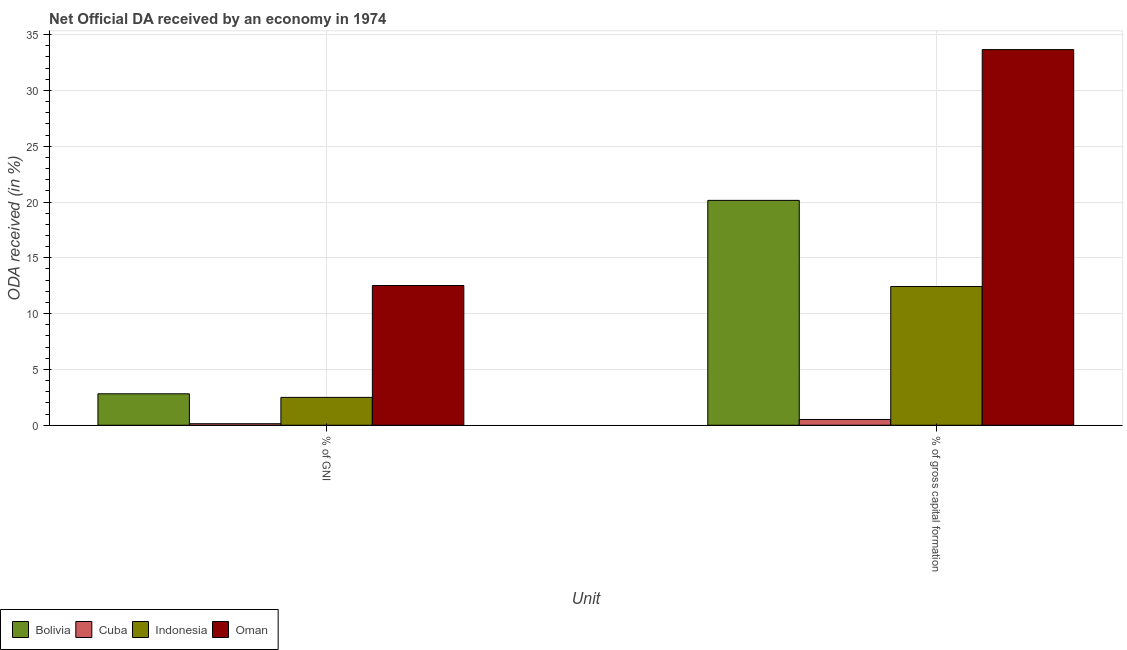How many different coloured bars are there?
Your answer should be compact. 4. Are the number of bars on each tick of the X-axis equal?
Your answer should be compact. Yes. How many bars are there on the 1st tick from the left?
Your answer should be compact. 4. How many bars are there on the 2nd tick from the right?
Offer a very short reply. 4. What is the label of the 2nd group of bars from the left?
Provide a succinct answer. % of gross capital formation. What is the oda received as percentage of gni in Indonesia?
Provide a succinct answer. 2.5. Across all countries, what is the maximum oda received as percentage of gross capital formation?
Keep it short and to the point. 33.65. Across all countries, what is the minimum oda received as percentage of gross capital formation?
Ensure brevity in your answer.  0.52. In which country was the oda received as percentage of gross capital formation maximum?
Offer a very short reply. Oman. In which country was the oda received as percentage of gross capital formation minimum?
Ensure brevity in your answer.  Cuba. What is the total oda received as percentage of gross capital formation in the graph?
Ensure brevity in your answer.  66.74. What is the difference between the oda received as percentage of gni in Indonesia and that in Bolivia?
Ensure brevity in your answer.  -0.32. What is the difference between the oda received as percentage of gni in Oman and the oda received as percentage of gross capital formation in Cuba?
Give a very brief answer. 12. What is the average oda received as percentage of gni per country?
Offer a terse response. 4.49. What is the difference between the oda received as percentage of gni and oda received as percentage of gross capital formation in Cuba?
Provide a succinct answer. -0.38. What is the ratio of the oda received as percentage of gni in Cuba to that in Bolivia?
Provide a short and direct response. 0.05. What does the 3rd bar from the right in % of GNI represents?
Your response must be concise. Cuba. Are all the bars in the graph horizontal?
Keep it short and to the point. No. How many countries are there in the graph?
Your answer should be compact. 4. What is the difference between two consecutive major ticks on the Y-axis?
Keep it short and to the point. 5. Where does the legend appear in the graph?
Keep it short and to the point. Bottom left. How many legend labels are there?
Your answer should be very brief. 4. What is the title of the graph?
Your response must be concise. Net Official DA received by an economy in 1974. What is the label or title of the X-axis?
Make the answer very short. Unit. What is the label or title of the Y-axis?
Your response must be concise. ODA received (in %). What is the ODA received (in %) in Bolivia in % of GNI?
Ensure brevity in your answer.  2.82. What is the ODA received (in %) of Cuba in % of GNI?
Offer a very short reply. 0.14. What is the ODA received (in %) in Indonesia in % of GNI?
Your answer should be compact. 2.5. What is the ODA received (in %) in Oman in % of GNI?
Ensure brevity in your answer.  12.52. What is the ODA received (in %) in Bolivia in % of gross capital formation?
Your answer should be compact. 20.15. What is the ODA received (in %) in Cuba in % of gross capital formation?
Your answer should be very brief. 0.52. What is the ODA received (in %) in Indonesia in % of gross capital formation?
Make the answer very short. 12.43. What is the ODA received (in %) in Oman in % of gross capital formation?
Offer a very short reply. 33.65. Across all Unit, what is the maximum ODA received (in %) in Bolivia?
Give a very brief answer. 20.15. Across all Unit, what is the maximum ODA received (in %) in Cuba?
Make the answer very short. 0.52. Across all Unit, what is the maximum ODA received (in %) in Indonesia?
Your response must be concise. 12.43. Across all Unit, what is the maximum ODA received (in %) in Oman?
Offer a very short reply. 33.65. Across all Unit, what is the minimum ODA received (in %) in Bolivia?
Provide a succinct answer. 2.82. Across all Unit, what is the minimum ODA received (in %) of Cuba?
Your answer should be compact. 0.14. Across all Unit, what is the minimum ODA received (in %) in Indonesia?
Provide a succinct answer. 2.5. Across all Unit, what is the minimum ODA received (in %) of Oman?
Your answer should be very brief. 12.52. What is the total ODA received (in %) of Bolivia in the graph?
Provide a short and direct response. 22.96. What is the total ODA received (in %) of Cuba in the graph?
Provide a short and direct response. 0.65. What is the total ODA received (in %) of Indonesia in the graph?
Offer a very short reply. 14.92. What is the total ODA received (in %) in Oman in the graph?
Your answer should be very brief. 46.17. What is the difference between the ODA received (in %) of Bolivia in % of GNI and that in % of gross capital formation?
Ensure brevity in your answer.  -17.33. What is the difference between the ODA received (in %) in Cuba in % of GNI and that in % of gross capital formation?
Your answer should be compact. -0.38. What is the difference between the ODA received (in %) in Indonesia in % of GNI and that in % of gross capital formation?
Your response must be concise. -9.93. What is the difference between the ODA received (in %) of Oman in % of GNI and that in % of gross capital formation?
Your response must be concise. -21.13. What is the difference between the ODA received (in %) of Bolivia in % of GNI and the ODA received (in %) of Cuba in % of gross capital formation?
Your response must be concise. 2.3. What is the difference between the ODA received (in %) of Bolivia in % of GNI and the ODA received (in %) of Indonesia in % of gross capital formation?
Offer a terse response. -9.61. What is the difference between the ODA received (in %) of Bolivia in % of GNI and the ODA received (in %) of Oman in % of gross capital formation?
Provide a succinct answer. -30.84. What is the difference between the ODA received (in %) of Cuba in % of GNI and the ODA received (in %) of Indonesia in % of gross capital formation?
Ensure brevity in your answer.  -12.29. What is the difference between the ODA received (in %) in Cuba in % of GNI and the ODA received (in %) in Oman in % of gross capital formation?
Your answer should be compact. -33.52. What is the difference between the ODA received (in %) in Indonesia in % of GNI and the ODA received (in %) in Oman in % of gross capital formation?
Offer a terse response. -31.16. What is the average ODA received (in %) of Bolivia per Unit?
Your response must be concise. 11.48. What is the average ODA received (in %) in Cuba per Unit?
Your answer should be very brief. 0.33. What is the average ODA received (in %) in Indonesia per Unit?
Your answer should be very brief. 7.46. What is the average ODA received (in %) in Oman per Unit?
Ensure brevity in your answer.  23.09. What is the difference between the ODA received (in %) of Bolivia and ODA received (in %) of Cuba in % of GNI?
Your answer should be very brief. 2.68. What is the difference between the ODA received (in %) in Bolivia and ODA received (in %) in Indonesia in % of GNI?
Give a very brief answer. 0.32. What is the difference between the ODA received (in %) of Bolivia and ODA received (in %) of Oman in % of GNI?
Provide a short and direct response. -9.7. What is the difference between the ODA received (in %) in Cuba and ODA received (in %) in Indonesia in % of GNI?
Ensure brevity in your answer.  -2.36. What is the difference between the ODA received (in %) of Cuba and ODA received (in %) of Oman in % of GNI?
Offer a very short reply. -12.38. What is the difference between the ODA received (in %) of Indonesia and ODA received (in %) of Oman in % of GNI?
Your answer should be very brief. -10.02. What is the difference between the ODA received (in %) of Bolivia and ODA received (in %) of Cuba in % of gross capital formation?
Your answer should be very brief. 19.63. What is the difference between the ODA received (in %) in Bolivia and ODA received (in %) in Indonesia in % of gross capital formation?
Make the answer very short. 7.72. What is the difference between the ODA received (in %) of Bolivia and ODA received (in %) of Oman in % of gross capital formation?
Make the answer very short. -13.51. What is the difference between the ODA received (in %) of Cuba and ODA received (in %) of Indonesia in % of gross capital formation?
Give a very brief answer. -11.91. What is the difference between the ODA received (in %) in Cuba and ODA received (in %) in Oman in % of gross capital formation?
Offer a terse response. -33.14. What is the difference between the ODA received (in %) in Indonesia and ODA received (in %) in Oman in % of gross capital formation?
Your answer should be very brief. -21.23. What is the ratio of the ODA received (in %) of Bolivia in % of GNI to that in % of gross capital formation?
Your answer should be compact. 0.14. What is the ratio of the ODA received (in %) in Cuba in % of GNI to that in % of gross capital formation?
Your response must be concise. 0.26. What is the ratio of the ODA received (in %) in Indonesia in % of GNI to that in % of gross capital formation?
Keep it short and to the point. 0.2. What is the ratio of the ODA received (in %) in Oman in % of GNI to that in % of gross capital formation?
Offer a terse response. 0.37. What is the difference between the highest and the second highest ODA received (in %) in Bolivia?
Your response must be concise. 17.33. What is the difference between the highest and the second highest ODA received (in %) of Cuba?
Your answer should be very brief. 0.38. What is the difference between the highest and the second highest ODA received (in %) in Indonesia?
Make the answer very short. 9.93. What is the difference between the highest and the second highest ODA received (in %) in Oman?
Make the answer very short. 21.13. What is the difference between the highest and the lowest ODA received (in %) in Bolivia?
Make the answer very short. 17.33. What is the difference between the highest and the lowest ODA received (in %) of Cuba?
Your response must be concise. 0.38. What is the difference between the highest and the lowest ODA received (in %) of Indonesia?
Give a very brief answer. 9.93. What is the difference between the highest and the lowest ODA received (in %) in Oman?
Ensure brevity in your answer.  21.13. 